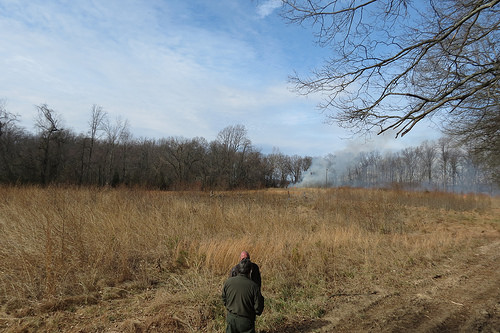<image>
Is the man behind the man? Yes. From this viewpoint, the man is positioned behind the man, with the man partially or fully occluding the man. 